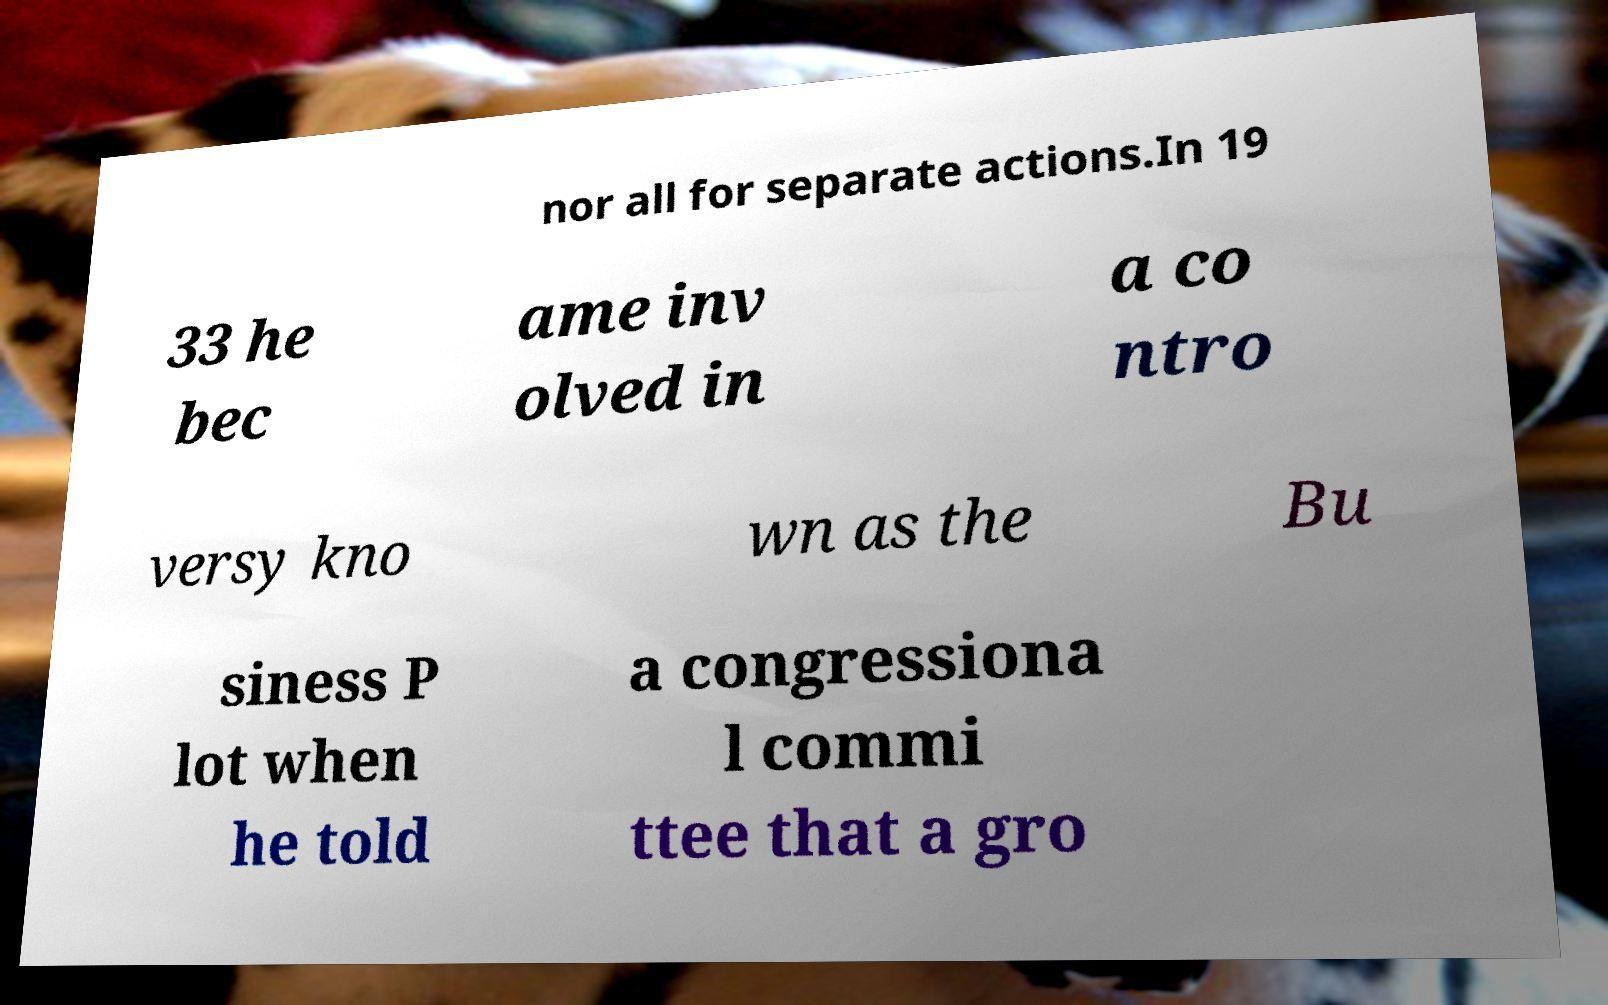Could you extract and type out the text from this image? nor all for separate actions.In 19 33 he bec ame inv olved in a co ntro versy kno wn as the Bu siness P lot when he told a congressiona l commi ttee that a gro 